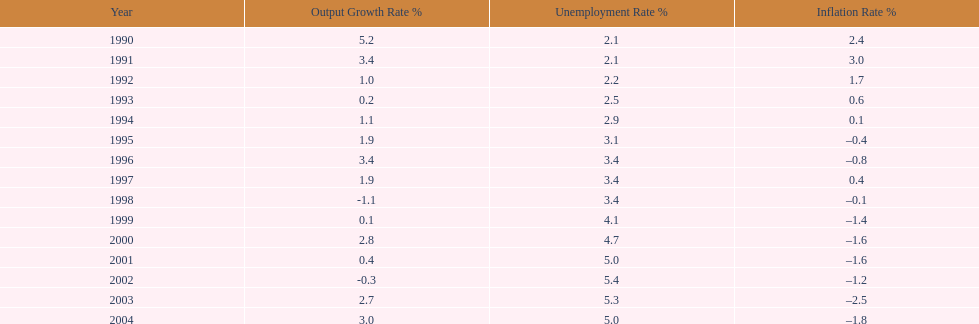When in the 1990s did the inflation rate initially turn negative? 1995. 